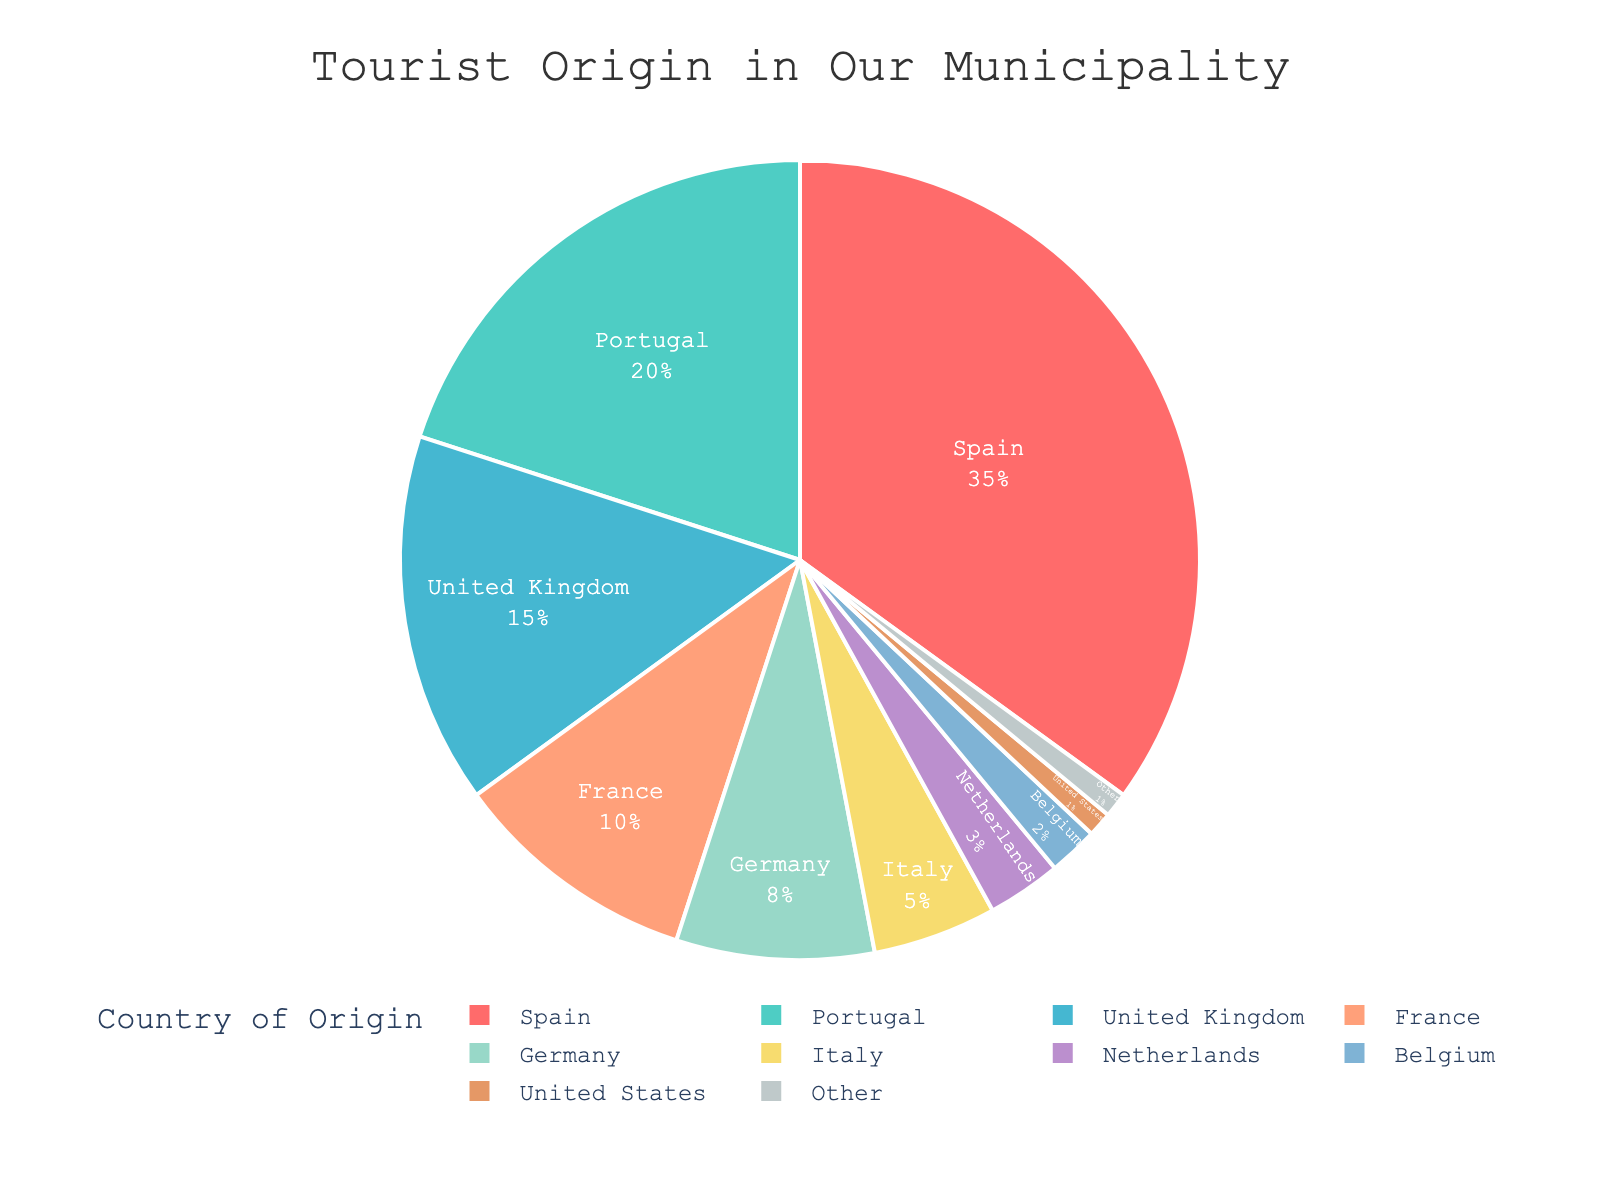which country has the highest percentage of tourists? The chart shows that Spain has the largest segment in the pie chart, representing the highest percentage of tourists.
Answer: Spain what is the combined percentage of tourists from Spain and Portugal? Spain accounts for 35% and Portugal for 20%. Adding these percentages gives a combined total: 35% + 20% = 55%.
Answer: 55% which country has a higher percentage of tourists, France or Germany? The pie chart indicates that France accounts for 10% of tourists, while Germany accounts for 8%. Thus, France has a higher percentage.
Answer: France how many countries contribute less than 5% of tourists each? According to the chart, the countries contributing less than 5% each are Netherlands (3%), Belgium (2%), United States (1%), and Other (1%). There are a total of 4 such countries.
Answer: 4 what is the percentage difference between tourists from the United Kingdom and Italy? The United Kingdom accounts for 15% of tourists, whereas Italy accounts for 5%. The difference is calculated as 15% - 5% = 10%.
Answer: 10% what percentage of tourists come from countries other than Spain, Portugal, and the United Kingdom combined? Spain, Portugal, and the United Kingdom together account for 35% + 20% + 15% = 70%. Thus, the percentage of tourists from other countries is 100% - 70% = 30%.
Answer: 30% arrange the countries in descending order of their tourist percentages. According to the chart, the order from highest to lowest percentage is: Spain (35%), Portugal (20%), United Kingdom (15%), France (10%), Germany (8%), Italy (5%), Netherlands (3%), Belgium (2%), United States (1%), Other (1%).
Answer: Spain, Portugal, United Kingdom, France, Germany, Italy, Netherlands, Belgium, United States, Other which country is represented by the light blue segment in the pie chart? The light blue color corresponds to the third segment, which represents the United Kingdom, based on the visual attributes of the chart.
Answer: United Kingdom what is the average percentage of tourists from Germany, Italy, and Netherlands? The percentages are Germany (8%), Italy (5%), and Netherlands (3%). The average is calculated by summing these and dividing by 3: (8% + 5% + 3%) / 3 = 5.33%.
Answer: 5.33% what proportion of tourists come from Belgium and the United States combined compared to those from Italy? Belgium and the United States together make up 2% + 1% = 3%. Italy alone accounts for 5%. The combined proportion is 3%/5% = 0.6. Thus, tourists from Belgium and the United States combined are 60% of those from Italy.
Answer: 60% 